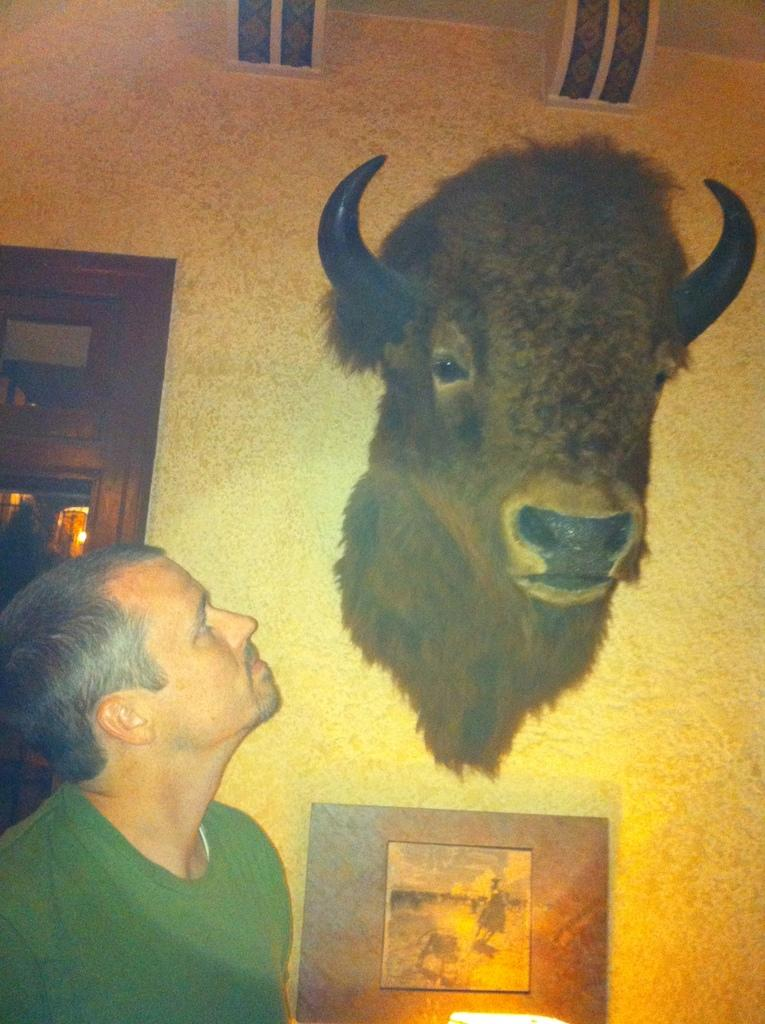Who is present in the image? There is a man in the image. What object can be seen in the image that is typically used for displaying photos? There is a photo frame in the image. What type of decoration is attached to the wall in the image? There is an animal head attached to the wall in the image. What type of snake can be seen slithering across the floor in the image? There is no snake present in the image; it only features a man, a photo frame, and an animal head on the wall. 